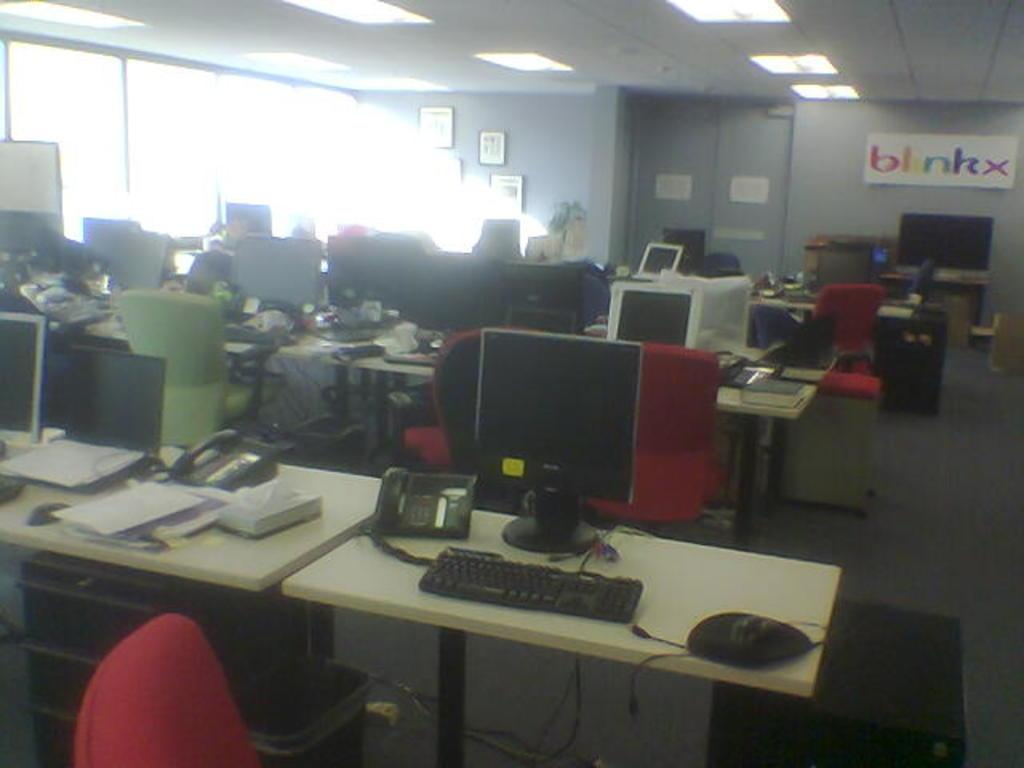Provide a one-sentence caption for the provided image. An office with many desks and computers and a sign on the wall that says "blinkx". 